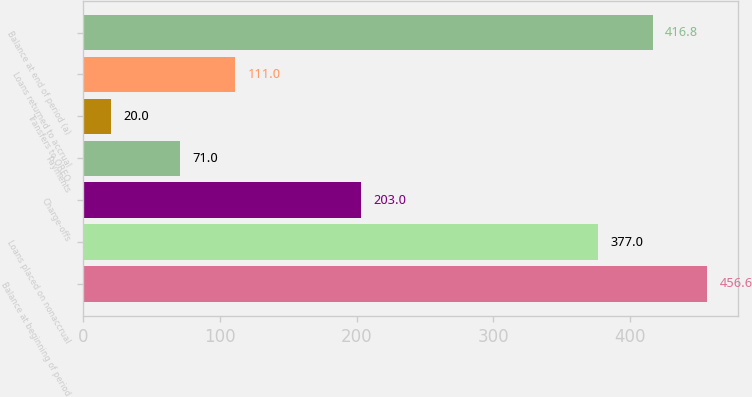Convert chart to OTSL. <chart><loc_0><loc_0><loc_500><loc_500><bar_chart><fcel>Balance at beginning of period<fcel>Loans placed on nonaccrual<fcel>Charge-offs<fcel>Payments<fcel>Transfers to OREO<fcel>Loans returned to accrual<fcel>Balance at end of period (a)<nl><fcel>456.6<fcel>377<fcel>203<fcel>71<fcel>20<fcel>111<fcel>416.8<nl></chart> 